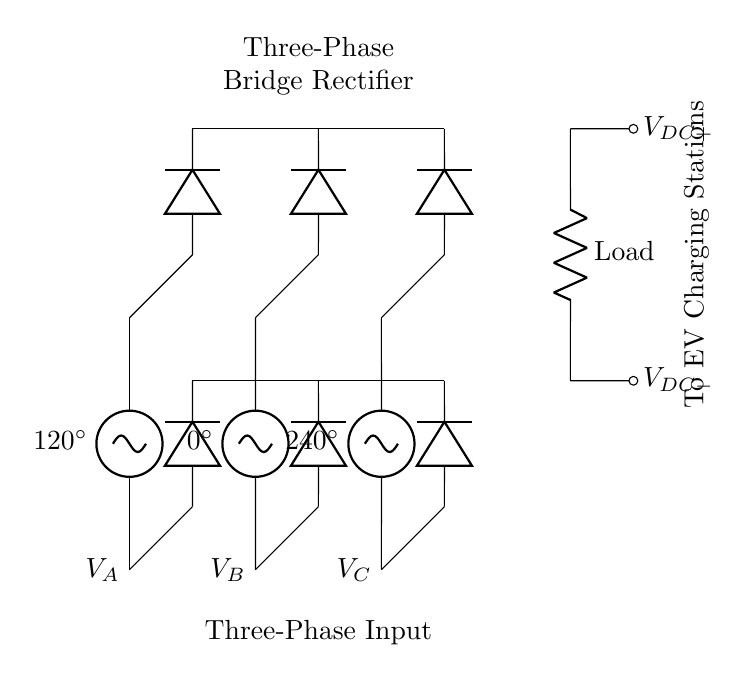What are the three phase voltages in the circuit? The circuit shows three phase voltages labeled as V_A, V_B, and V_C, corresponding to phase angles of 120 degrees, 0 degrees, and 240 degrees.
Answer: V_A, V_B, V_C What types of components are used in this circuit? The circuit comprises three diodes used for rectification and a resistor representing the load.
Answer: Diodes and resistor How many diodes are connected in this rectifier system? There are six diodes arranged in a bridge configuration for the three-phase rectifier system: three for each phase voltage and three for the negative output.
Answer: Six What is the purpose of the load in this context? The load represents the electric vehicle charging stations, where the DC output is supplied for charging purposes.
Answer: To charge electric vehicles What type of rectifier is illustrated in this circuit diagram? The circuit illustrates a three-phase bridge rectifier, which converts three-phase AC input to a DC output.
Answer: Three-phase bridge rectifier How do the diodes connect to the AC sources? Each of the three phase voltages connects to the anodes of two diodes each, while the cathodes of these diodes connect to a common DC output.
Answer: Diodes are connected to AC sources and DC output What is the voltage configuration between the DC output terminals? The DC output terminals, labeled V_DC+ and V_DC-, depict a positive and a negative output voltage relative to the load.
Answer: Positive and negative output voltages 